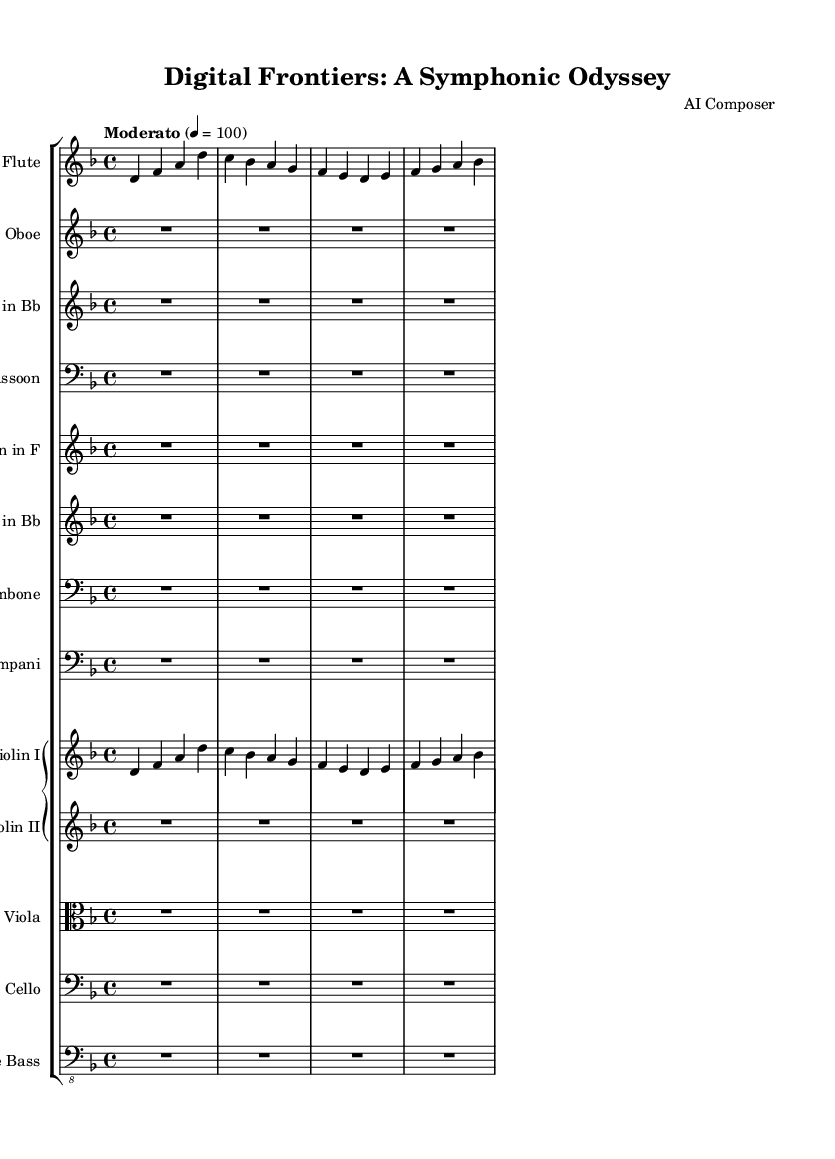What is the key signature of this music? The key signature is D minor, as indicated by the presence of one flat (B flat) in the key signature section.
Answer: D minor What is the time signature of the piece? The time signature is 4/4, as written at the beginning of the score after the key signature. This indicates there are four beats in each measure, and the quarter note gets one beat.
Answer: 4/4 What tempo marking is indicated for the piece? The tempo marking is "Moderato," which suggests a moderately paced performance. The specific tempo of 100 beats per minute is indicated.
Answer: Moderato What is the name of the piece composed? The title of the piece is "Digital Frontiers: A Symphonic Odyssey," as seen in the header section at the top of the score.
Answer: Digital Frontiers: A Symphonic Odyssey What instruments are included in the score? The instruments listed in the score include Flute, Oboe, Clarinet in B flat, Bassoon, Horn in F, Trumpet in B flat, Trombone, Timpani, Violin I, Violin II, Viola, Cello, and Double Bass. Each instrument has its own staff in the score.
Answer: Flute, Oboe, Clarinet in B flat, Bassoon, Horn in F, Trumpet in B flat, Trombone, Timpani, Violin I, Violin II, Viola, Cello, Double Bass How many measures of rest does the Oboe play at the beginning? The Oboe has a whole measure of rest represented by the symbol "R1*4," which means one full measure of rest, equivalent to four beats of silence.
Answer: 1 measure What influences does the title hint at regarding the theme of the composition? The title "Digital Frontiers: A Symphonic Odyssey" suggests themes related to technology, particularly internet governance, and the evolving landscape of cyber law. This reflects a modern symphonic approach addressing contemporary issues.
Answer: Technology and Cyber Law 